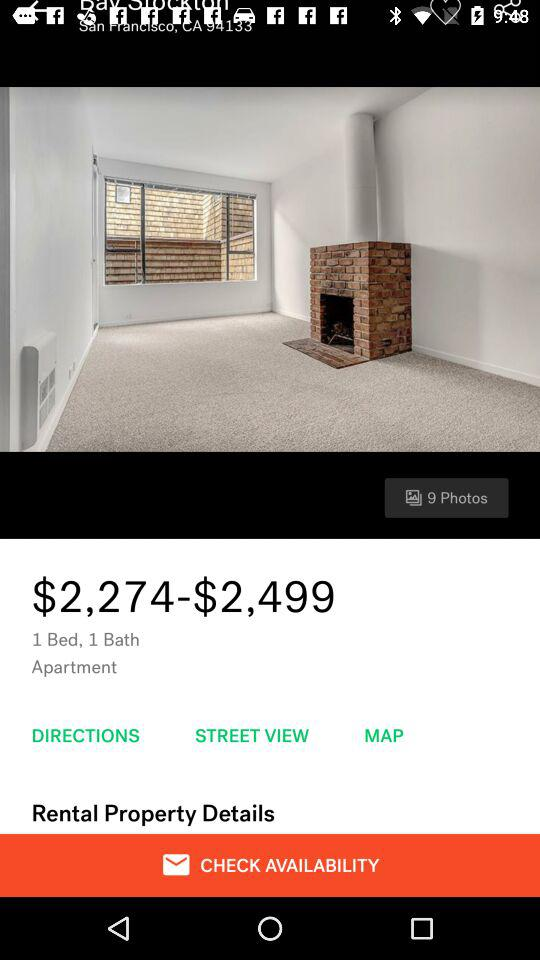How many beds does the apartment have?
Answer the question using a single word or phrase. 1 